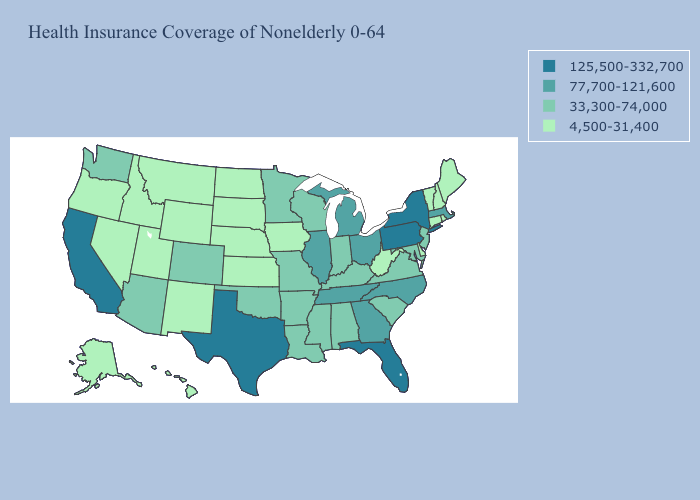Does the map have missing data?
Quick response, please. No. Does Indiana have a higher value than Florida?
Write a very short answer. No. Does Idaho have a higher value than Tennessee?
Quick response, please. No. What is the value of Michigan?
Give a very brief answer. 77,700-121,600. Name the states that have a value in the range 125,500-332,700?
Keep it brief. California, Florida, New York, Pennsylvania, Texas. Name the states that have a value in the range 77,700-121,600?
Write a very short answer. Georgia, Illinois, Massachusetts, Michigan, North Carolina, Ohio, Tennessee. What is the value of Louisiana?
Quick response, please. 33,300-74,000. Does Hawaii have the same value as Maine?
Write a very short answer. Yes. What is the value of Alabama?
Be succinct. 33,300-74,000. Does the map have missing data?
Be succinct. No. Does Oregon have a lower value than Nebraska?
Be succinct. No. What is the value of Louisiana?
Keep it brief. 33,300-74,000. Does Arizona have a higher value than Wyoming?
Quick response, please. Yes. What is the lowest value in states that border Missouri?
Answer briefly. 4,500-31,400. What is the value of Connecticut?
Be succinct. 4,500-31,400. 